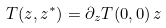Convert formula to latex. <formula><loc_0><loc_0><loc_500><loc_500>T ( z , z ^ { * } ) = \partial _ { z } T ( 0 , 0 ) \, z \,</formula> 